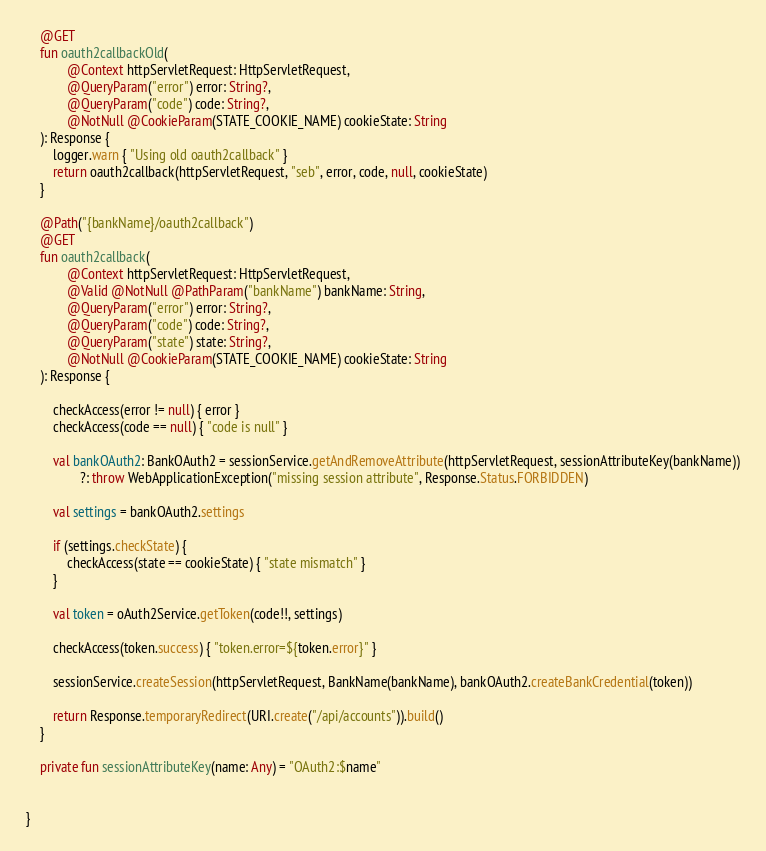<code> <loc_0><loc_0><loc_500><loc_500><_Kotlin_>    @GET
    fun oauth2callbackOld(
            @Context httpServletRequest: HttpServletRequest,
            @QueryParam("error") error: String?,
            @QueryParam("code") code: String?,
            @NotNull @CookieParam(STATE_COOKIE_NAME) cookieState: String
    ): Response {
        logger.warn { "Using old oauth2callback" }
        return oauth2callback(httpServletRequest, "seb", error, code, null, cookieState)
    }

    @Path("{bankName}/oauth2callback")
    @GET
    fun oauth2callback(
            @Context httpServletRequest: HttpServletRequest,
            @Valid @NotNull @PathParam("bankName") bankName: String,
            @QueryParam("error") error: String?,
            @QueryParam("code") code: String?,
            @QueryParam("state") state: String?,
            @NotNull @CookieParam(STATE_COOKIE_NAME) cookieState: String
    ): Response {

        checkAccess(error != null) { error }
        checkAccess(code == null) { "code is null" }

        val bankOAuth2: BankOAuth2 = sessionService.getAndRemoveAttribute(httpServletRequest, sessionAttributeKey(bankName))
                ?: throw WebApplicationException("missing session attribute", Response.Status.FORBIDDEN)

        val settings = bankOAuth2.settings

        if (settings.checkState) {
            checkAccess(state == cookieState) { "state mismatch" }
        }

        val token = oAuth2Service.getToken(code!!, settings)

        checkAccess(token.success) { "token.error=${token.error}" }

        sessionService.createSession(httpServletRequest, BankName(bankName), bankOAuth2.createBankCredential(token))

        return Response.temporaryRedirect(URI.create("/api/accounts")).build()
    }

    private fun sessionAttributeKey(name: Any) = "OAuth2:$name"


}
</code> 